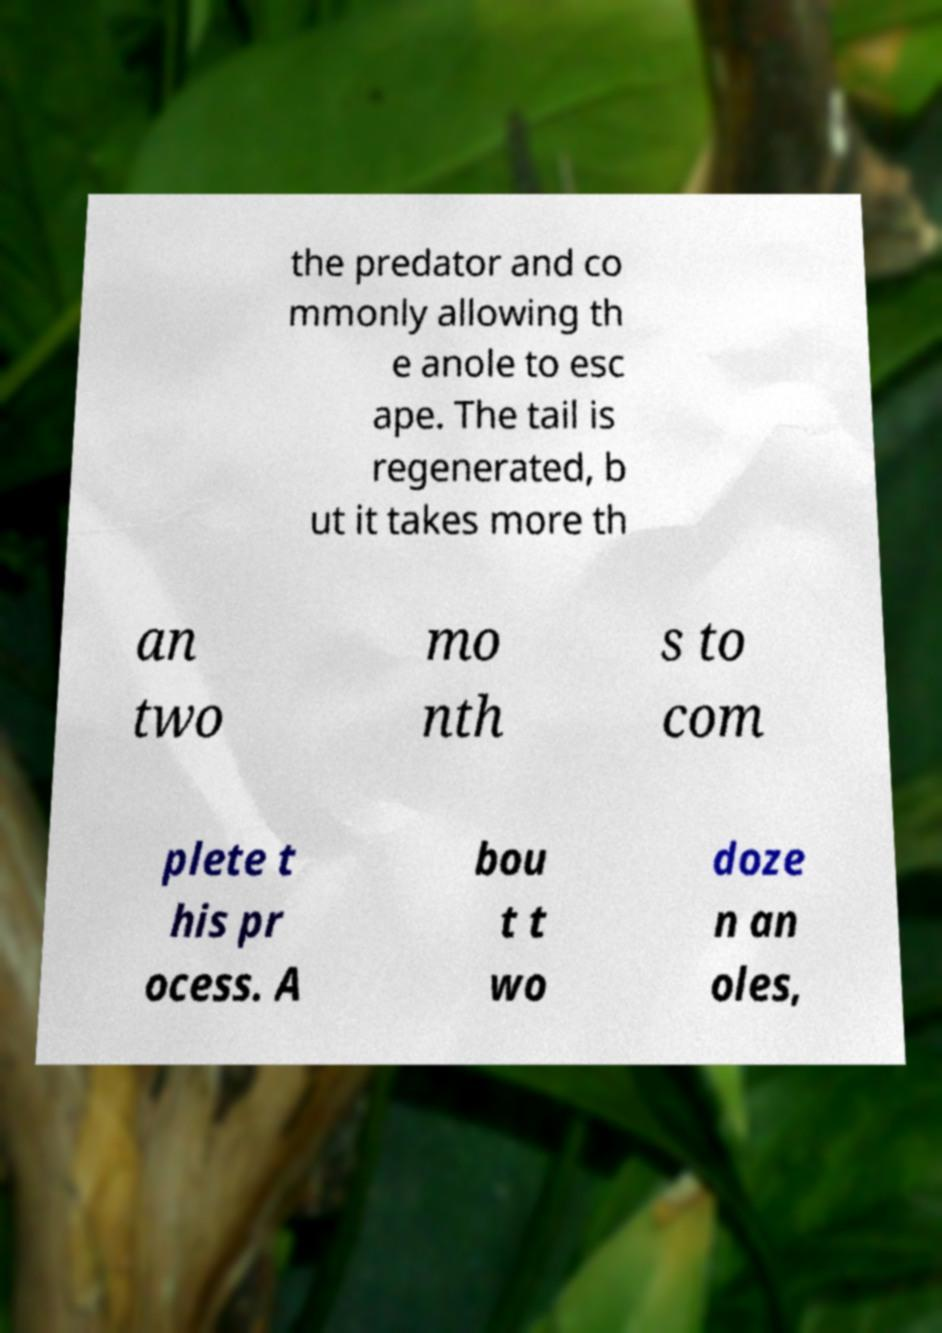I need the written content from this picture converted into text. Can you do that? the predator and co mmonly allowing th e anole to esc ape. The tail is regenerated, b ut it takes more th an two mo nth s to com plete t his pr ocess. A bou t t wo doze n an oles, 